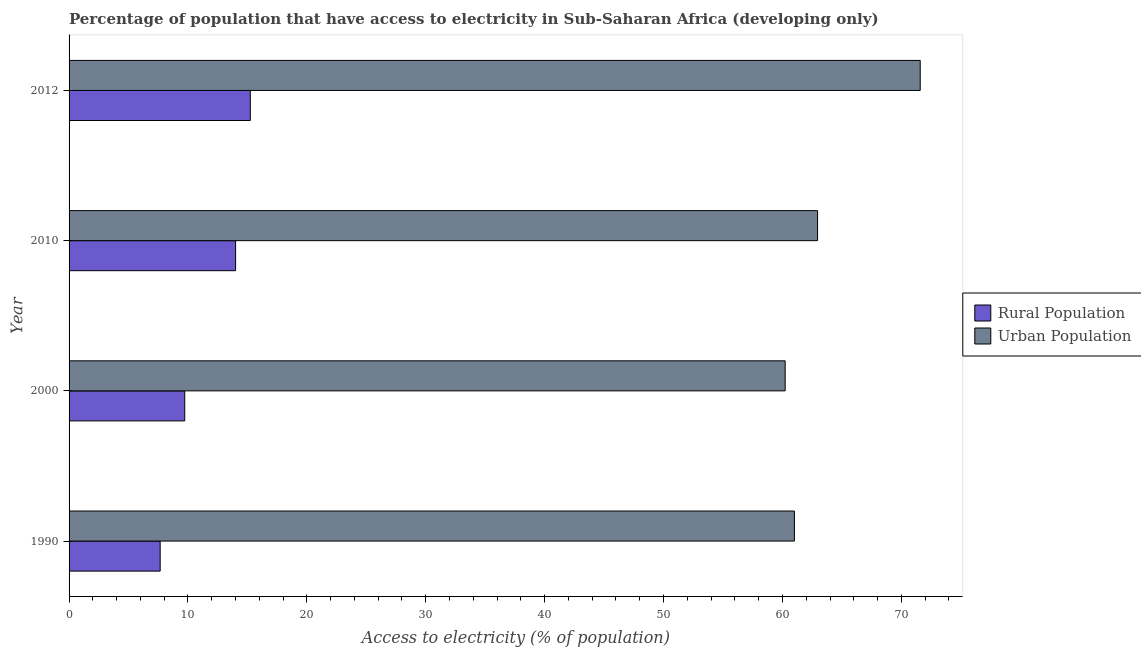How many groups of bars are there?
Your response must be concise. 4. Are the number of bars on each tick of the Y-axis equal?
Your answer should be very brief. Yes. What is the label of the 4th group of bars from the top?
Your answer should be compact. 1990. In how many cases, is the number of bars for a given year not equal to the number of legend labels?
Offer a very short reply. 0. What is the percentage of rural population having access to electricity in 2010?
Keep it short and to the point. 14.01. Across all years, what is the maximum percentage of urban population having access to electricity?
Keep it short and to the point. 71.59. Across all years, what is the minimum percentage of rural population having access to electricity?
Your answer should be very brief. 7.66. In which year was the percentage of urban population having access to electricity maximum?
Offer a very short reply. 2012. In which year was the percentage of rural population having access to electricity minimum?
Your answer should be compact. 1990. What is the total percentage of rural population having access to electricity in the graph?
Your answer should be compact. 46.64. What is the difference between the percentage of rural population having access to electricity in 2010 and that in 2012?
Make the answer very short. -1.24. What is the difference between the percentage of rural population having access to electricity in 2012 and the percentage of urban population having access to electricity in 2010?
Your answer should be compact. -47.71. What is the average percentage of rural population having access to electricity per year?
Provide a succinct answer. 11.66. In the year 2012, what is the difference between the percentage of rural population having access to electricity and percentage of urban population having access to electricity?
Provide a short and direct response. -56.34. In how many years, is the percentage of rural population having access to electricity greater than 48 %?
Provide a short and direct response. 0. Is the difference between the percentage of urban population having access to electricity in 1990 and 2012 greater than the difference between the percentage of rural population having access to electricity in 1990 and 2012?
Offer a very short reply. No. What is the difference between the highest and the second highest percentage of rural population having access to electricity?
Your response must be concise. 1.24. What is the difference between the highest and the lowest percentage of urban population having access to electricity?
Keep it short and to the point. 11.36. Is the sum of the percentage of rural population having access to electricity in 2000 and 2010 greater than the maximum percentage of urban population having access to electricity across all years?
Provide a short and direct response. No. What does the 1st bar from the top in 2012 represents?
Make the answer very short. Urban Population. What does the 1st bar from the bottom in 2010 represents?
Your answer should be compact. Rural Population. Are all the bars in the graph horizontal?
Give a very brief answer. Yes. How many years are there in the graph?
Provide a short and direct response. 4. Does the graph contain grids?
Offer a very short reply. No. What is the title of the graph?
Offer a very short reply. Percentage of population that have access to electricity in Sub-Saharan Africa (developing only). What is the label or title of the X-axis?
Provide a succinct answer. Access to electricity (% of population). What is the Access to electricity (% of population) in Rural Population in 1990?
Ensure brevity in your answer.  7.66. What is the Access to electricity (% of population) in Urban Population in 1990?
Offer a very short reply. 61.01. What is the Access to electricity (% of population) of Rural Population in 2000?
Give a very brief answer. 9.73. What is the Access to electricity (% of population) in Urban Population in 2000?
Your answer should be very brief. 60.23. What is the Access to electricity (% of population) in Rural Population in 2010?
Keep it short and to the point. 14.01. What is the Access to electricity (% of population) of Urban Population in 2010?
Ensure brevity in your answer.  62.95. What is the Access to electricity (% of population) of Rural Population in 2012?
Give a very brief answer. 15.24. What is the Access to electricity (% of population) of Urban Population in 2012?
Your answer should be very brief. 71.59. Across all years, what is the maximum Access to electricity (% of population) of Rural Population?
Give a very brief answer. 15.24. Across all years, what is the maximum Access to electricity (% of population) of Urban Population?
Ensure brevity in your answer.  71.59. Across all years, what is the minimum Access to electricity (% of population) in Rural Population?
Provide a short and direct response. 7.66. Across all years, what is the minimum Access to electricity (% of population) in Urban Population?
Keep it short and to the point. 60.23. What is the total Access to electricity (% of population) of Rural Population in the graph?
Offer a very short reply. 46.64. What is the total Access to electricity (% of population) in Urban Population in the graph?
Offer a very short reply. 255.78. What is the difference between the Access to electricity (% of population) of Rural Population in 1990 and that in 2000?
Provide a succinct answer. -2.06. What is the difference between the Access to electricity (% of population) of Urban Population in 1990 and that in 2000?
Make the answer very short. 0.78. What is the difference between the Access to electricity (% of population) of Rural Population in 1990 and that in 2010?
Offer a very short reply. -6.34. What is the difference between the Access to electricity (% of population) in Urban Population in 1990 and that in 2010?
Ensure brevity in your answer.  -1.95. What is the difference between the Access to electricity (% of population) in Rural Population in 1990 and that in 2012?
Your answer should be compact. -7.58. What is the difference between the Access to electricity (% of population) of Urban Population in 1990 and that in 2012?
Give a very brief answer. -10.58. What is the difference between the Access to electricity (% of population) of Rural Population in 2000 and that in 2010?
Your response must be concise. -4.28. What is the difference between the Access to electricity (% of population) in Urban Population in 2000 and that in 2010?
Offer a terse response. -2.73. What is the difference between the Access to electricity (% of population) in Rural Population in 2000 and that in 2012?
Provide a succinct answer. -5.52. What is the difference between the Access to electricity (% of population) in Urban Population in 2000 and that in 2012?
Your answer should be very brief. -11.36. What is the difference between the Access to electricity (% of population) in Rural Population in 2010 and that in 2012?
Offer a terse response. -1.24. What is the difference between the Access to electricity (% of population) of Urban Population in 2010 and that in 2012?
Your answer should be very brief. -8.63. What is the difference between the Access to electricity (% of population) in Rural Population in 1990 and the Access to electricity (% of population) in Urban Population in 2000?
Your answer should be very brief. -52.57. What is the difference between the Access to electricity (% of population) in Rural Population in 1990 and the Access to electricity (% of population) in Urban Population in 2010?
Offer a very short reply. -55.29. What is the difference between the Access to electricity (% of population) in Rural Population in 1990 and the Access to electricity (% of population) in Urban Population in 2012?
Provide a succinct answer. -63.92. What is the difference between the Access to electricity (% of population) in Rural Population in 2000 and the Access to electricity (% of population) in Urban Population in 2010?
Give a very brief answer. -53.23. What is the difference between the Access to electricity (% of population) of Rural Population in 2000 and the Access to electricity (% of population) of Urban Population in 2012?
Your answer should be compact. -61.86. What is the difference between the Access to electricity (% of population) of Rural Population in 2010 and the Access to electricity (% of population) of Urban Population in 2012?
Ensure brevity in your answer.  -57.58. What is the average Access to electricity (% of population) in Rural Population per year?
Give a very brief answer. 11.66. What is the average Access to electricity (% of population) in Urban Population per year?
Offer a very short reply. 63.94. In the year 1990, what is the difference between the Access to electricity (% of population) of Rural Population and Access to electricity (% of population) of Urban Population?
Keep it short and to the point. -53.34. In the year 2000, what is the difference between the Access to electricity (% of population) in Rural Population and Access to electricity (% of population) in Urban Population?
Offer a terse response. -50.5. In the year 2010, what is the difference between the Access to electricity (% of population) in Rural Population and Access to electricity (% of population) in Urban Population?
Ensure brevity in your answer.  -48.95. In the year 2012, what is the difference between the Access to electricity (% of population) in Rural Population and Access to electricity (% of population) in Urban Population?
Ensure brevity in your answer.  -56.34. What is the ratio of the Access to electricity (% of population) of Rural Population in 1990 to that in 2000?
Your answer should be compact. 0.79. What is the ratio of the Access to electricity (% of population) in Urban Population in 1990 to that in 2000?
Your response must be concise. 1.01. What is the ratio of the Access to electricity (% of population) of Rural Population in 1990 to that in 2010?
Your answer should be very brief. 0.55. What is the ratio of the Access to electricity (% of population) of Rural Population in 1990 to that in 2012?
Make the answer very short. 0.5. What is the ratio of the Access to electricity (% of population) in Urban Population in 1990 to that in 2012?
Give a very brief answer. 0.85. What is the ratio of the Access to electricity (% of population) of Rural Population in 2000 to that in 2010?
Provide a short and direct response. 0.69. What is the ratio of the Access to electricity (% of population) in Urban Population in 2000 to that in 2010?
Offer a terse response. 0.96. What is the ratio of the Access to electricity (% of population) of Rural Population in 2000 to that in 2012?
Ensure brevity in your answer.  0.64. What is the ratio of the Access to electricity (% of population) of Urban Population in 2000 to that in 2012?
Your answer should be compact. 0.84. What is the ratio of the Access to electricity (% of population) of Rural Population in 2010 to that in 2012?
Your answer should be compact. 0.92. What is the ratio of the Access to electricity (% of population) of Urban Population in 2010 to that in 2012?
Offer a very short reply. 0.88. What is the difference between the highest and the second highest Access to electricity (% of population) of Rural Population?
Offer a very short reply. 1.24. What is the difference between the highest and the second highest Access to electricity (% of population) of Urban Population?
Offer a very short reply. 8.63. What is the difference between the highest and the lowest Access to electricity (% of population) of Rural Population?
Make the answer very short. 7.58. What is the difference between the highest and the lowest Access to electricity (% of population) in Urban Population?
Provide a succinct answer. 11.36. 